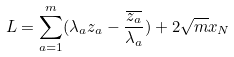Convert formula to latex. <formula><loc_0><loc_0><loc_500><loc_500>L = \sum _ { a = 1 } ^ { m } ( \lambda _ { a } z _ { a } - \frac { \overline { z _ { a } } } { \lambda _ { a } } ) + 2 \sqrt { m } x _ { N }</formula> 